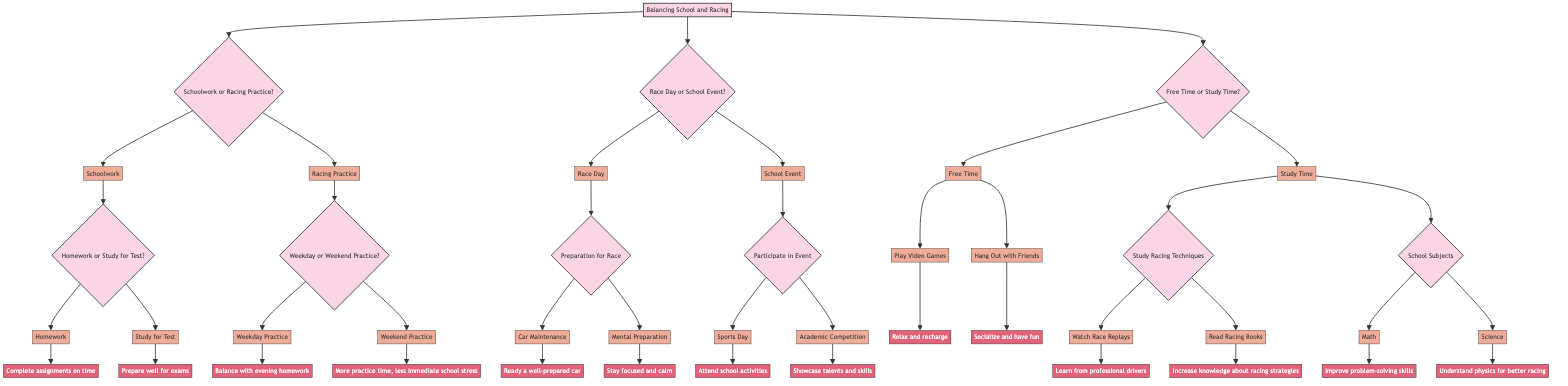What are the two main decisions at the root of the diagram? The diagram starts with "Balancing School and Racing" and splits into three main decision points: "Schoolwork or Racing Practice," "Race Day or School Event," and "Free Time or Study Time." Therefore, the two main decisions are "Schoolwork or Racing Practice" and "Race Day or School Event."
Answer: Schoolwork or Racing Practice, Race Day or School Event How many options can you choose from "Schoolwork or Racing Practice"? At the "Schoolwork or Racing Practice" decision point, there are two options available: "Schoolwork" and "Racing Practice."
Answer: 2 What is the outcome of selecting "Homework"? Choosing "Homework" leads to the outcome "Complete assignments on time," indicating that this option helps manage academic responsibilities effectively.
Answer: Complete assignments on time What happens if you select "Weekend Practice" instead of "Weekday Practice"? Selecting "Weekend Practice" results in the outcome "More practice time, less immediate school stress," which suggests that practicing on weekends offers more extensive practice opportunities and alleviates pressure from school tasks.
Answer: More practice time, less immediate school stress If you choose "Race Day," what is the first decision that follows it? After choosing "Race Day," the next decision point is "Preparation for Race," where you need to decide how to prepare for the upcoming race.
Answer: Preparation for Race What are the two actions you can take for mental preparation before a race? When preparing mentally for the race, you can select either "Car Maintenance" to ensure the car is ready or "Mental Preparation" to stay focused and calm.
Answer: Car Maintenance, Mental Preparation What are the two activities you can do during "Free Time"? In the "Free Time" decision, the activities are "Play Video Games" or "Hang Out with Friends," providing options for relaxation and socializing.
Answer: Play Video Games, Hang Out with Friends Which study subject will help you understand physics for better racing? The "Science" option under "School Subjects" suggests that studying this subject will enhance your understanding of physics, which is crucial for racing dynamics.
Answer: Science What is the outcome of studying racing techniques through watching race replays? If you choose to study racing techniques by "Watching Race Replays," the outcome is "Learn from professional drivers," emphasizing the benefit of observing skilled drivers to improve your own racing skills.
Answer: Learn from professional drivers 